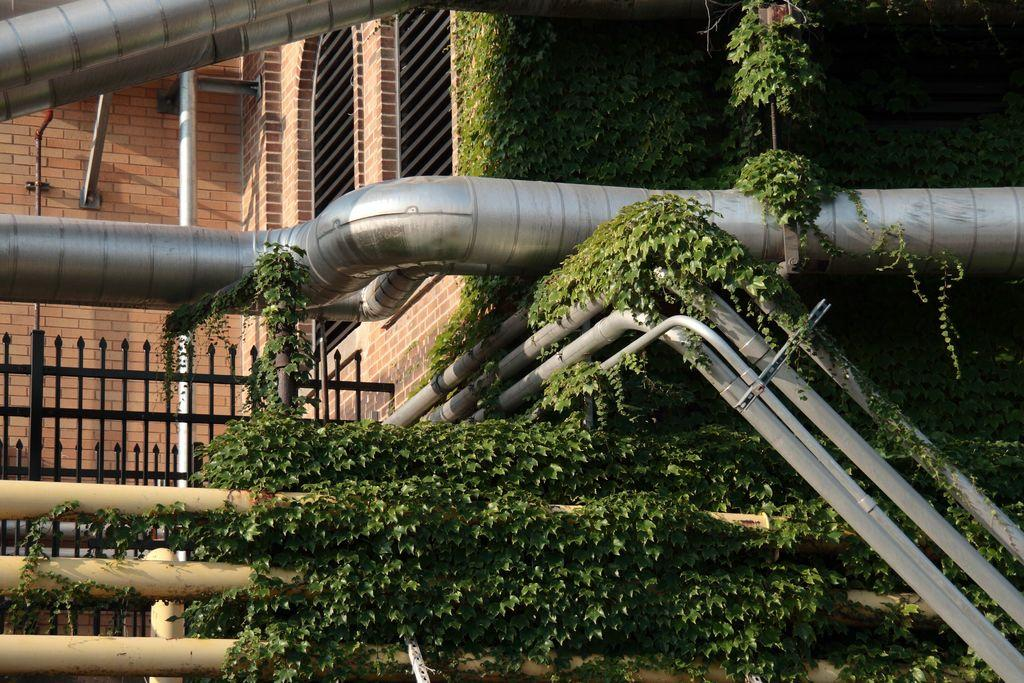What type of objects can be seen in the image? There are metal rods and creepers in the image. What is visible in the background of the image? There is fencing, a wall, and a window in the background of the image. What type of key is used to unlock the houses in the image? There are no houses present in the image, so it is not possible to determine what type of key might be used to unlock them. 